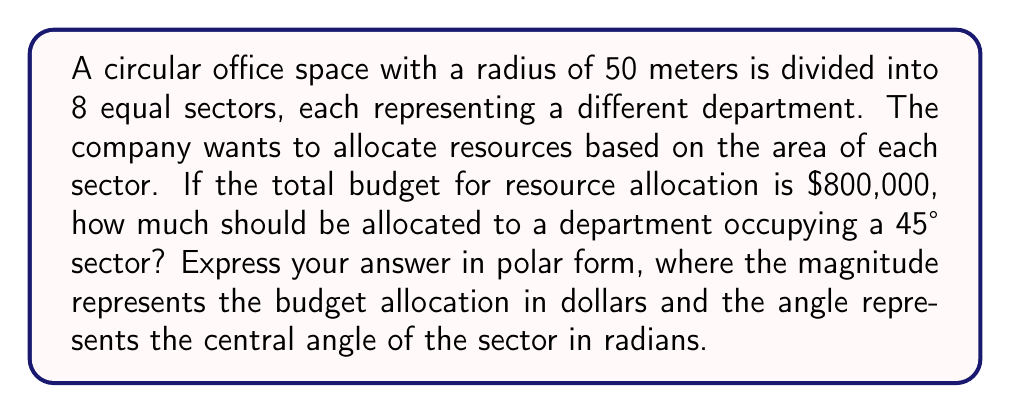Provide a solution to this math problem. To solve this problem, we need to follow these steps:

1. Calculate the area of the entire circular office space:
   $$A_{total} = \pi r^2 = \pi (50\text{ m})^2 = 7853.98\text{ m}^2$$

2. Calculate the area of a 45° sector:
   The area of a sector is given by $A_{sector} = \frac{\theta}{2\pi} \pi r^2$, where $\theta$ is the central angle in radians.
   $$\theta = 45° = \frac{45\pi}{180} = \frac{\pi}{4}\text{ radians}$$
   $$A_{sector} = \frac{\frac{\pi}{4}}{2\pi} \pi r^2 = \frac{1}{8} \pi r^2 = \frac{1}{8} (7853.98\text{ m}^2) = 981.75\text{ m}^2$$

3. Calculate the proportion of the total area occupied by the 45° sector:
   $$\text{Proportion} = \frac{A_{sector}}{A_{total}} = \frac{981.75\text{ m}^2}{7853.98\text{ m}^2} = \frac{1}{8} = 0.125$$

4. Calculate the budget allocation for the 45° sector:
   $$\text{Budget allocation} = 0.125 \times \$800,000 = \$100,000$$

5. Express the result in polar form:
   The magnitude is the budget allocation: $100,000
   The angle is the central angle of the sector in radians: $\frac{\pi}{4}$

   In polar form: $(100000, \frac{\pi}{4})$
Answer: $(100000, \frac{\pi}{4})$ 